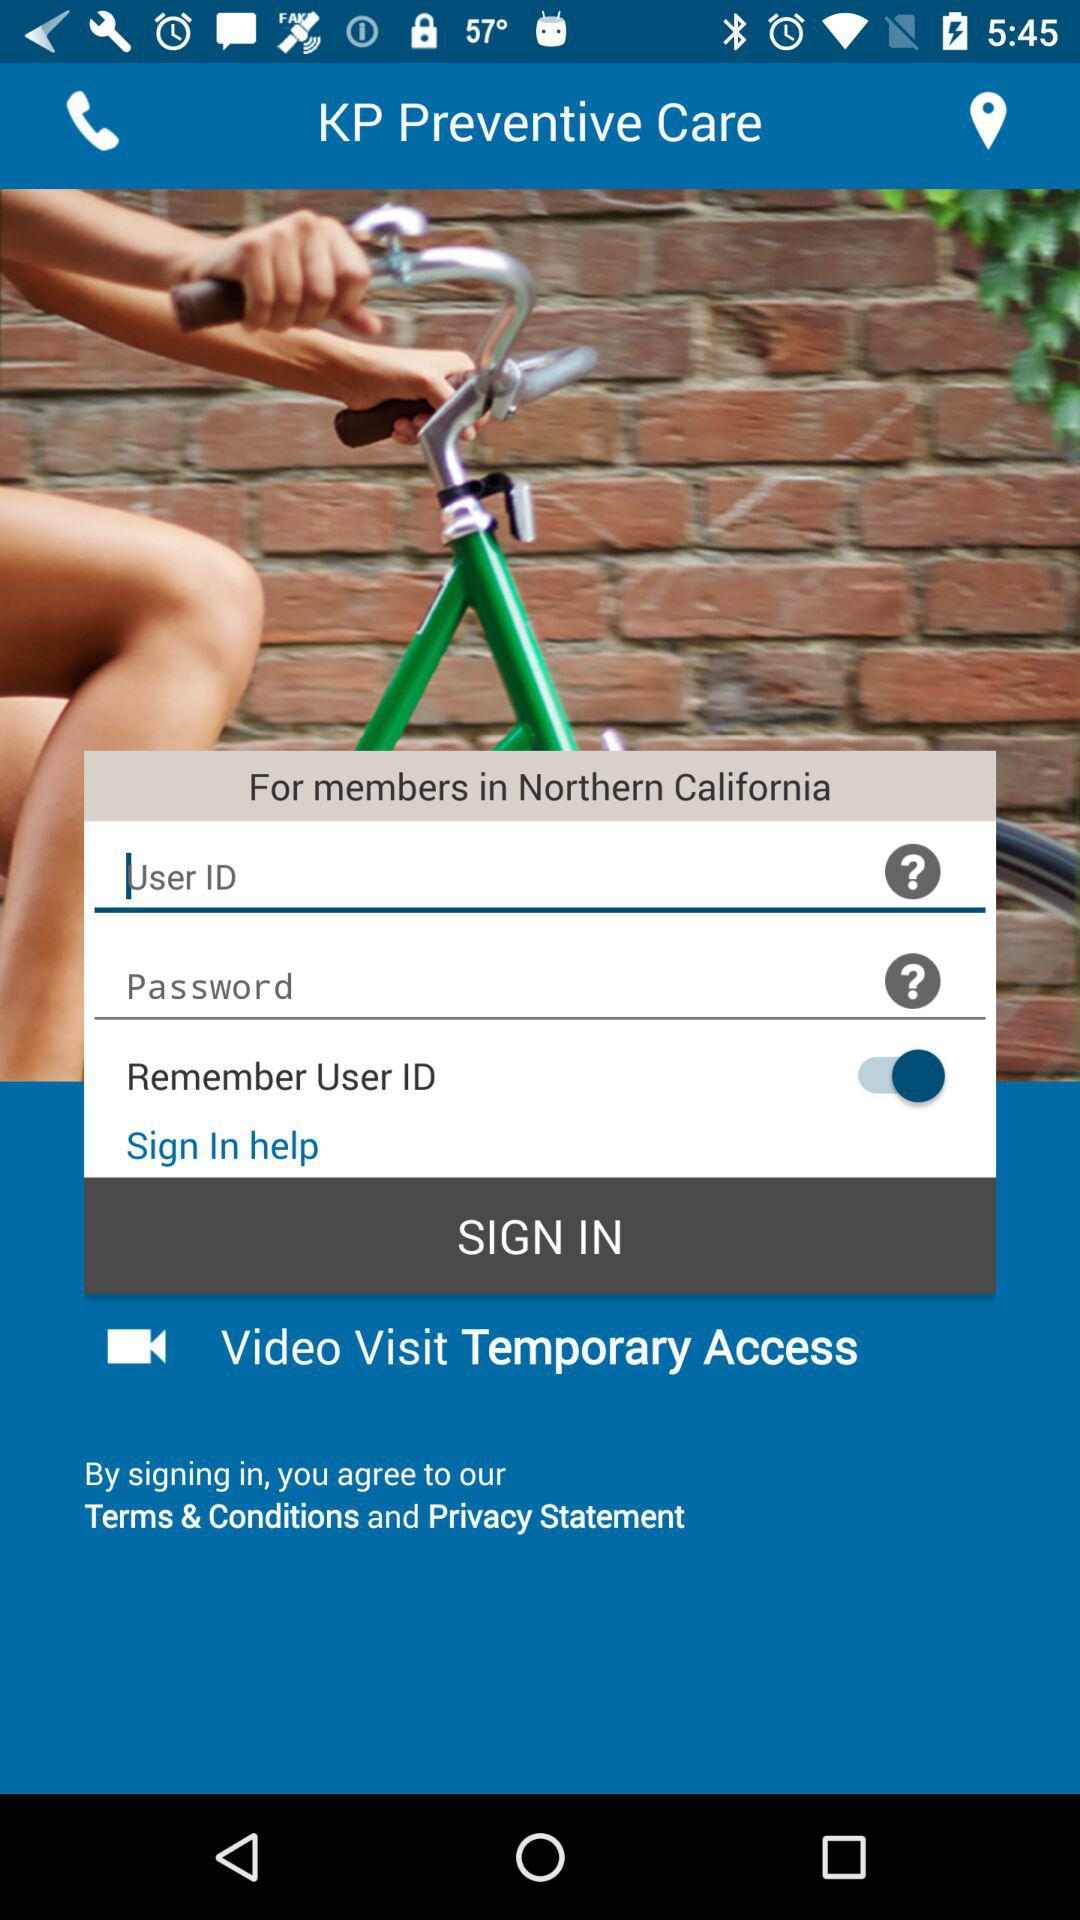What is the status of Remember User ID? The status is on. 